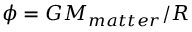Convert formula to latex. <formula><loc_0><loc_0><loc_500><loc_500>\phi = G M _ { m a t t e r } / R</formula> 